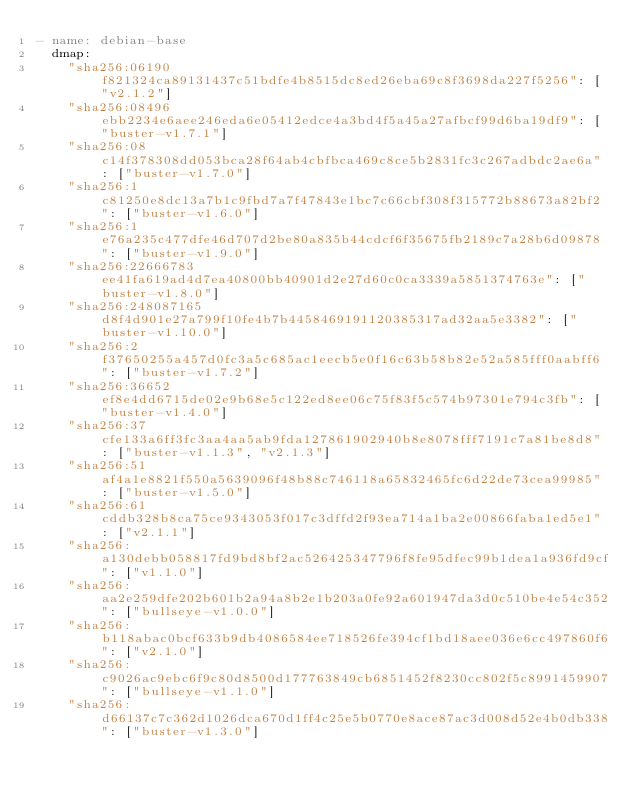Convert code to text. <code><loc_0><loc_0><loc_500><loc_500><_YAML_>- name: debian-base
  dmap:
    "sha256:06190f821324ca89131437c51bdfe4b8515dc8ed26eba69c8f3698da227f5256": ["v2.1.2"]
    "sha256:08496ebb2234e6aee246eda6e05412edce4a3bd4f5a45a27afbcf99d6ba19df9": ["buster-v1.7.1"]
    "sha256:08c14f378308dd053bca28f64ab4cbfbca469c8ce5b2831fc3c267adbdc2ae6a": ["buster-v1.7.0"]
    "sha256:1c81250e8dc13a7b1c9fbd7a7f47843e1bc7c66cbf308f315772b88673a82bf2": ["buster-v1.6.0"]
    "sha256:1e76a235c477dfe46d707d2be80a835b44cdcf6f35675fb2189c7a28b6d09878": ["buster-v1.9.0"]
    "sha256:22666783ee41fa619ad4d7ea40800bb40901d2e27d60c0ca3339a5851374763e": ["buster-v1.8.0"]
    "sha256:248087165d8f4d901e27a799f10fe4b7b4458469191120385317ad32aa5e3382": ["buster-v1.10.0"]
    "sha256:2f37650255a457d0fc3a5c685ac1eecb5e0f16c63b58b82e52a585fff0aabff6": ["buster-v1.7.2"]
    "sha256:36652ef8e4dd6715de02e9b68e5c122ed8ee06c75f83f5c574b97301e794c3fb": ["buster-v1.4.0"]
    "sha256:37cfe133a6ff3fc3aa4aa5ab9fda127861902940b8e8078fff7191c7a81be8d8": ["buster-v1.1.3", "v2.1.3"]
    "sha256:51af4a1e8821f550a5639096f48b88c746118a65832465fc6d22de73cea99985": ["buster-v1.5.0"]
    "sha256:61cddb328b8ca75ce9343053f017c3dffd2f93ea714a1ba2e00866faba1ed5e1": ["v2.1.1"]
    "sha256:a130debb058817fd9bd8bf2ac526425347796f8fe95dfec99b1dea1a936fd9cf": ["v1.1.0"]
    "sha256:aa2e259dfe202b601b2a94a8b2e1b203a0fe92a601947da3d0c510be4e54c352": ["bullseye-v1.0.0"]
    "sha256:b118abac0bcf633b9db4086584ee718526fe394cf1bd18aee036e6cc497860f6": ["v2.1.0"]
    "sha256:c9026ac9ebc6f9c80d8500d177763849cb6851452f8230cc802f5c8991459907": ["bullseye-v1.1.0"]
    "sha256:d66137c7c362d1026dca670d1ff4c25e5b0770e8ace87ac3d008d52e4b0db338": ["buster-v1.3.0"]</code> 